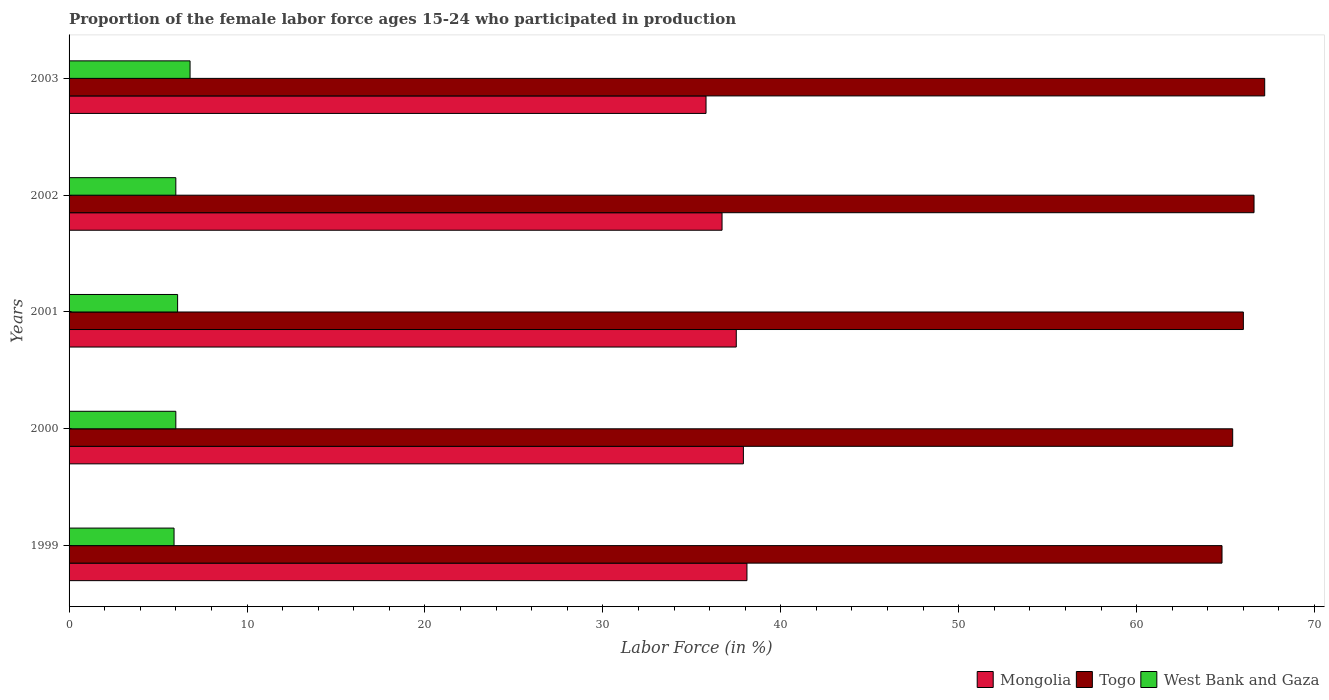What is the label of the 2nd group of bars from the top?
Provide a succinct answer. 2002. What is the proportion of the female labor force who participated in production in Mongolia in 2000?
Make the answer very short. 37.9. Across all years, what is the maximum proportion of the female labor force who participated in production in West Bank and Gaza?
Your answer should be compact. 6.8. Across all years, what is the minimum proportion of the female labor force who participated in production in West Bank and Gaza?
Provide a short and direct response. 5.9. In which year was the proportion of the female labor force who participated in production in Mongolia maximum?
Ensure brevity in your answer.  1999. What is the total proportion of the female labor force who participated in production in Togo in the graph?
Offer a terse response. 330. What is the difference between the proportion of the female labor force who participated in production in Mongolia in 1999 and that in 2000?
Your answer should be compact. 0.2. What is the difference between the proportion of the female labor force who participated in production in Mongolia in 1999 and the proportion of the female labor force who participated in production in Togo in 2002?
Offer a terse response. -28.5. What is the average proportion of the female labor force who participated in production in Mongolia per year?
Give a very brief answer. 37.2. In the year 2001, what is the difference between the proportion of the female labor force who participated in production in Togo and proportion of the female labor force who participated in production in West Bank and Gaza?
Provide a succinct answer. 59.9. What is the ratio of the proportion of the female labor force who participated in production in Togo in 1999 to that in 2000?
Give a very brief answer. 0.99. Is the proportion of the female labor force who participated in production in West Bank and Gaza in 1999 less than that in 2002?
Your answer should be very brief. Yes. What is the difference between the highest and the second highest proportion of the female labor force who participated in production in West Bank and Gaza?
Your response must be concise. 0.7. What is the difference between the highest and the lowest proportion of the female labor force who participated in production in West Bank and Gaza?
Offer a terse response. 0.9. Is the sum of the proportion of the female labor force who participated in production in West Bank and Gaza in 2000 and 2001 greater than the maximum proportion of the female labor force who participated in production in Togo across all years?
Make the answer very short. No. What does the 3rd bar from the top in 2002 represents?
Provide a short and direct response. Mongolia. What does the 1st bar from the bottom in 2001 represents?
Provide a succinct answer. Mongolia. Is it the case that in every year, the sum of the proportion of the female labor force who participated in production in Mongolia and proportion of the female labor force who participated in production in Togo is greater than the proportion of the female labor force who participated in production in West Bank and Gaza?
Provide a succinct answer. Yes. Where does the legend appear in the graph?
Your answer should be compact. Bottom right. How are the legend labels stacked?
Provide a succinct answer. Horizontal. What is the title of the graph?
Offer a terse response. Proportion of the female labor force ages 15-24 who participated in production. What is the label or title of the X-axis?
Provide a succinct answer. Labor Force (in %). What is the label or title of the Y-axis?
Your answer should be compact. Years. What is the Labor Force (in %) in Mongolia in 1999?
Offer a very short reply. 38.1. What is the Labor Force (in %) of Togo in 1999?
Keep it short and to the point. 64.8. What is the Labor Force (in %) in West Bank and Gaza in 1999?
Your response must be concise. 5.9. What is the Labor Force (in %) in Mongolia in 2000?
Provide a succinct answer. 37.9. What is the Labor Force (in %) of Togo in 2000?
Your response must be concise. 65.4. What is the Labor Force (in %) in Mongolia in 2001?
Offer a very short reply. 37.5. What is the Labor Force (in %) of West Bank and Gaza in 2001?
Offer a very short reply. 6.1. What is the Labor Force (in %) in Mongolia in 2002?
Make the answer very short. 36.7. What is the Labor Force (in %) in Togo in 2002?
Ensure brevity in your answer.  66.6. What is the Labor Force (in %) of West Bank and Gaza in 2002?
Ensure brevity in your answer.  6. What is the Labor Force (in %) in Mongolia in 2003?
Offer a very short reply. 35.8. What is the Labor Force (in %) of Togo in 2003?
Ensure brevity in your answer.  67.2. What is the Labor Force (in %) in West Bank and Gaza in 2003?
Your answer should be very brief. 6.8. Across all years, what is the maximum Labor Force (in %) of Mongolia?
Give a very brief answer. 38.1. Across all years, what is the maximum Labor Force (in %) of Togo?
Ensure brevity in your answer.  67.2. Across all years, what is the maximum Labor Force (in %) of West Bank and Gaza?
Offer a very short reply. 6.8. Across all years, what is the minimum Labor Force (in %) in Mongolia?
Provide a short and direct response. 35.8. Across all years, what is the minimum Labor Force (in %) of Togo?
Keep it short and to the point. 64.8. Across all years, what is the minimum Labor Force (in %) in West Bank and Gaza?
Provide a succinct answer. 5.9. What is the total Labor Force (in %) of Mongolia in the graph?
Make the answer very short. 186. What is the total Labor Force (in %) in Togo in the graph?
Ensure brevity in your answer.  330. What is the total Labor Force (in %) in West Bank and Gaza in the graph?
Ensure brevity in your answer.  30.8. What is the difference between the Labor Force (in %) in Mongolia in 1999 and that in 2000?
Provide a short and direct response. 0.2. What is the difference between the Labor Force (in %) in Togo in 1999 and that in 2000?
Your answer should be compact. -0.6. What is the difference between the Labor Force (in %) in West Bank and Gaza in 1999 and that in 2000?
Give a very brief answer. -0.1. What is the difference between the Labor Force (in %) in Mongolia in 1999 and that in 2001?
Your answer should be compact. 0.6. What is the difference between the Labor Force (in %) of West Bank and Gaza in 1999 and that in 2001?
Your answer should be very brief. -0.2. What is the difference between the Labor Force (in %) in Togo in 1999 and that in 2002?
Your response must be concise. -1.8. What is the difference between the Labor Force (in %) in Mongolia in 1999 and that in 2003?
Ensure brevity in your answer.  2.3. What is the difference between the Labor Force (in %) in Mongolia in 2000 and that in 2001?
Provide a succinct answer. 0.4. What is the difference between the Labor Force (in %) of Togo in 2000 and that in 2001?
Your answer should be very brief. -0.6. What is the difference between the Labor Force (in %) in Mongolia in 2000 and that in 2002?
Your answer should be very brief. 1.2. What is the difference between the Labor Force (in %) of Togo in 2000 and that in 2002?
Make the answer very short. -1.2. What is the difference between the Labor Force (in %) of West Bank and Gaza in 2000 and that in 2002?
Offer a very short reply. 0. What is the difference between the Labor Force (in %) in Togo in 2000 and that in 2003?
Keep it short and to the point. -1.8. What is the difference between the Labor Force (in %) of Mongolia in 2001 and that in 2002?
Your answer should be compact. 0.8. What is the difference between the Labor Force (in %) in Togo in 2001 and that in 2002?
Ensure brevity in your answer.  -0.6. What is the difference between the Labor Force (in %) of West Bank and Gaza in 2001 and that in 2002?
Offer a terse response. 0.1. What is the difference between the Labor Force (in %) in Mongolia in 2002 and that in 2003?
Provide a short and direct response. 0.9. What is the difference between the Labor Force (in %) in Mongolia in 1999 and the Labor Force (in %) in Togo in 2000?
Make the answer very short. -27.3. What is the difference between the Labor Force (in %) of Mongolia in 1999 and the Labor Force (in %) of West Bank and Gaza in 2000?
Provide a succinct answer. 32.1. What is the difference between the Labor Force (in %) in Togo in 1999 and the Labor Force (in %) in West Bank and Gaza in 2000?
Keep it short and to the point. 58.8. What is the difference between the Labor Force (in %) in Mongolia in 1999 and the Labor Force (in %) in Togo in 2001?
Your response must be concise. -27.9. What is the difference between the Labor Force (in %) in Togo in 1999 and the Labor Force (in %) in West Bank and Gaza in 2001?
Provide a succinct answer. 58.7. What is the difference between the Labor Force (in %) in Mongolia in 1999 and the Labor Force (in %) in Togo in 2002?
Provide a succinct answer. -28.5. What is the difference between the Labor Force (in %) of Mongolia in 1999 and the Labor Force (in %) of West Bank and Gaza in 2002?
Provide a short and direct response. 32.1. What is the difference between the Labor Force (in %) in Togo in 1999 and the Labor Force (in %) in West Bank and Gaza in 2002?
Keep it short and to the point. 58.8. What is the difference between the Labor Force (in %) of Mongolia in 1999 and the Labor Force (in %) of Togo in 2003?
Provide a short and direct response. -29.1. What is the difference between the Labor Force (in %) in Mongolia in 1999 and the Labor Force (in %) in West Bank and Gaza in 2003?
Provide a succinct answer. 31.3. What is the difference between the Labor Force (in %) in Mongolia in 2000 and the Labor Force (in %) in Togo in 2001?
Provide a short and direct response. -28.1. What is the difference between the Labor Force (in %) of Mongolia in 2000 and the Labor Force (in %) of West Bank and Gaza in 2001?
Your answer should be compact. 31.8. What is the difference between the Labor Force (in %) in Togo in 2000 and the Labor Force (in %) in West Bank and Gaza in 2001?
Your response must be concise. 59.3. What is the difference between the Labor Force (in %) of Mongolia in 2000 and the Labor Force (in %) of Togo in 2002?
Keep it short and to the point. -28.7. What is the difference between the Labor Force (in %) of Mongolia in 2000 and the Labor Force (in %) of West Bank and Gaza in 2002?
Provide a short and direct response. 31.9. What is the difference between the Labor Force (in %) in Togo in 2000 and the Labor Force (in %) in West Bank and Gaza in 2002?
Your answer should be compact. 59.4. What is the difference between the Labor Force (in %) in Mongolia in 2000 and the Labor Force (in %) in Togo in 2003?
Ensure brevity in your answer.  -29.3. What is the difference between the Labor Force (in %) of Mongolia in 2000 and the Labor Force (in %) of West Bank and Gaza in 2003?
Give a very brief answer. 31.1. What is the difference between the Labor Force (in %) in Togo in 2000 and the Labor Force (in %) in West Bank and Gaza in 2003?
Keep it short and to the point. 58.6. What is the difference between the Labor Force (in %) of Mongolia in 2001 and the Labor Force (in %) of Togo in 2002?
Your answer should be very brief. -29.1. What is the difference between the Labor Force (in %) of Mongolia in 2001 and the Labor Force (in %) of West Bank and Gaza in 2002?
Your answer should be very brief. 31.5. What is the difference between the Labor Force (in %) of Togo in 2001 and the Labor Force (in %) of West Bank and Gaza in 2002?
Your answer should be very brief. 60. What is the difference between the Labor Force (in %) of Mongolia in 2001 and the Labor Force (in %) of Togo in 2003?
Give a very brief answer. -29.7. What is the difference between the Labor Force (in %) of Mongolia in 2001 and the Labor Force (in %) of West Bank and Gaza in 2003?
Your answer should be very brief. 30.7. What is the difference between the Labor Force (in %) of Togo in 2001 and the Labor Force (in %) of West Bank and Gaza in 2003?
Your response must be concise. 59.2. What is the difference between the Labor Force (in %) of Mongolia in 2002 and the Labor Force (in %) of Togo in 2003?
Your answer should be compact. -30.5. What is the difference between the Labor Force (in %) of Mongolia in 2002 and the Labor Force (in %) of West Bank and Gaza in 2003?
Provide a succinct answer. 29.9. What is the difference between the Labor Force (in %) of Togo in 2002 and the Labor Force (in %) of West Bank and Gaza in 2003?
Offer a terse response. 59.8. What is the average Labor Force (in %) in Mongolia per year?
Your response must be concise. 37.2. What is the average Labor Force (in %) in Togo per year?
Ensure brevity in your answer.  66. What is the average Labor Force (in %) of West Bank and Gaza per year?
Keep it short and to the point. 6.16. In the year 1999, what is the difference between the Labor Force (in %) in Mongolia and Labor Force (in %) in Togo?
Offer a terse response. -26.7. In the year 1999, what is the difference between the Labor Force (in %) of Mongolia and Labor Force (in %) of West Bank and Gaza?
Offer a terse response. 32.2. In the year 1999, what is the difference between the Labor Force (in %) in Togo and Labor Force (in %) in West Bank and Gaza?
Give a very brief answer. 58.9. In the year 2000, what is the difference between the Labor Force (in %) in Mongolia and Labor Force (in %) in Togo?
Offer a very short reply. -27.5. In the year 2000, what is the difference between the Labor Force (in %) of Mongolia and Labor Force (in %) of West Bank and Gaza?
Your answer should be compact. 31.9. In the year 2000, what is the difference between the Labor Force (in %) in Togo and Labor Force (in %) in West Bank and Gaza?
Ensure brevity in your answer.  59.4. In the year 2001, what is the difference between the Labor Force (in %) in Mongolia and Labor Force (in %) in Togo?
Offer a terse response. -28.5. In the year 2001, what is the difference between the Labor Force (in %) in Mongolia and Labor Force (in %) in West Bank and Gaza?
Ensure brevity in your answer.  31.4. In the year 2001, what is the difference between the Labor Force (in %) of Togo and Labor Force (in %) of West Bank and Gaza?
Your answer should be very brief. 59.9. In the year 2002, what is the difference between the Labor Force (in %) of Mongolia and Labor Force (in %) of Togo?
Your answer should be compact. -29.9. In the year 2002, what is the difference between the Labor Force (in %) in Mongolia and Labor Force (in %) in West Bank and Gaza?
Give a very brief answer. 30.7. In the year 2002, what is the difference between the Labor Force (in %) in Togo and Labor Force (in %) in West Bank and Gaza?
Your response must be concise. 60.6. In the year 2003, what is the difference between the Labor Force (in %) in Mongolia and Labor Force (in %) in Togo?
Offer a very short reply. -31.4. In the year 2003, what is the difference between the Labor Force (in %) of Togo and Labor Force (in %) of West Bank and Gaza?
Offer a very short reply. 60.4. What is the ratio of the Labor Force (in %) in Mongolia in 1999 to that in 2000?
Ensure brevity in your answer.  1.01. What is the ratio of the Labor Force (in %) in West Bank and Gaza in 1999 to that in 2000?
Your answer should be compact. 0.98. What is the ratio of the Labor Force (in %) in Togo in 1999 to that in 2001?
Ensure brevity in your answer.  0.98. What is the ratio of the Labor Force (in %) in West Bank and Gaza in 1999 to that in 2001?
Provide a succinct answer. 0.97. What is the ratio of the Labor Force (in %) in Mongolia in 1999 to that in 2002?
Your answer should be compact. 1.04. What is the ratio of the Labor Force (in %) in West Bank and Gaza in 1999 to that in 2002?
Offer a very short reply. 0.98. What is the ratio of the Labor Force (in %) in Mongolia in 1999 to that in 2003?
Offer a very short reply. 1.06. What is the ratio of the Labor Force (in %) in Togo in 1999 to that in 2003?
Your answer should be compact. 0.96. What is the ratio of the Labor Force (in %) in West Bank and Gaza in 1999 to that in 2003?
Your answer should be very brief. 0.87. What is the ratio of the Labor Force (in %) of Mongolia in 2000 to that in 2001?
Provide a short and direct response. 1.01. What is the ratio of the Labor Force (in %) of Togo in 2000 to that in 2001?
Your answer should be compact. 0.99. What is the ratio of the Labor Force (in %) in West Bank and Gaza in 2000 to that in 2001?
Give a very brief answer. 0.98. What is the ratio of the Labor Force (in %) of Mongolia in 2000 to that in 2002?
Give a very brief answer. 1.03. What is the ratio of the Labor Force (in %) in Mongolia in 2000 to that in 2003?
Keep it short and to the point. 1.06. What is the ratio of the Labor Force (in %) of Togo in 2000 to that in 2003?
Ensure brevity in your answer.  0.97. What is the ratio of the Labor Force (in %) in West Bank and Gaza in 2000 to that in 2003?
Offer a terse response. 0.88. What is the ratio of the Labor Force (in %) in Mongolia in 2001 to that in 2002?
Provide a short and direct response. 1.02. What is the ratio of the Labor Force (in %) in Togo in 2001 to that in 2002?
Your answer should be compact. 0.99. What is the ratio of the Labor Force (in %) of West Bank and Gaza in 2001 to that in 2002?
Your answer should be compact. 1.02. What is the ratio of the Labor Force (in %) of Mongolia in 2001 to that in 2003?
Keep it short and to the point. 1.05. What is the ratio of the Labor Force (in %) in Togo in 2001 to that in 2003?
Ensure brevity in your answer.  0.98. What is the ratio of the Labor Force (in %) of West Bank and Gaza in 2001 to that in 2003?
Your response must be concise. 0.9. What is the ratio of the Labor Force (in %) in Mongolia in 2002 to that in 2003?
Your answer should be compact. 1.03. What is the ratio of the Labor Force (in %) in Togo in 2002 to that in 2003?
Your answer should be very brief. 0.99. What is the ratio of the Labor Force (in %) in West Bank and Gaza in 2002 to that in 2003?
Your answer should be very brief. 0.88. What is the difference between the highest and the second highest Labor Force (in %) in Mongolia?
Keep it short and to the point. 0.2. What is the difference between the highest and the second highest Labor Force (in %) in Togo?
Give a very brief answer. 0.6. What is the difference between the highest and the lowest Labor Force (in %) of West Bank and Gaza?
Make the answer very short. 0.9. 